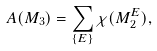<formula> <loc_0><loc_0><loc_500><loc_500>A ( M _ { 3 } ) = \sum _ { \{ E \} } \chi ( M _ { 2 } ^ { E } ) ,</formula> 